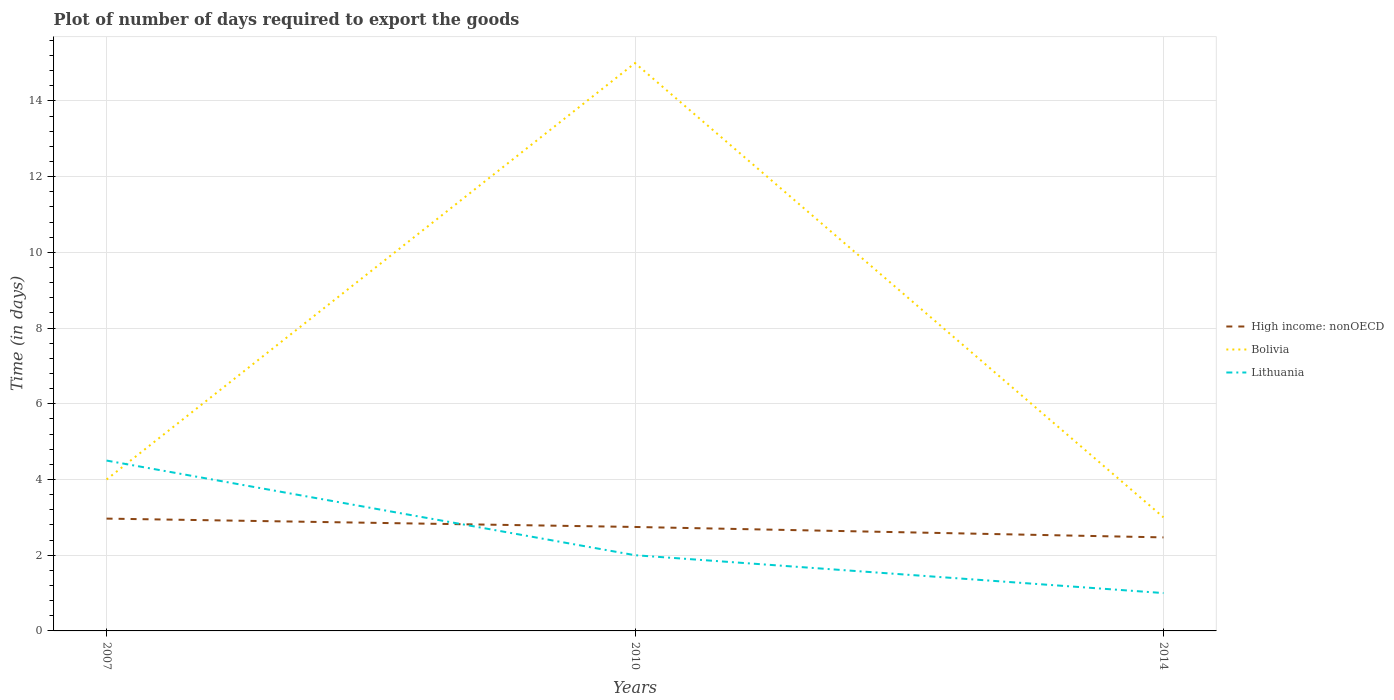Across all years, what is the maximum time required to export goods in Bolivia?
Your answer should be very brief. 3. In which year was the time required to export goods in High income: nonOECD maximum?
Provide a short and direct response. 2014. What is the total time required to export goods in Lithuania in the graph?
Provide a succinct answer. 3.5. What is the difference between the highest and the second highest time required to export goods in High income: nonOECD?
Keep it short and to the point. 0.5. Is the time required to export goods in Bolivia strictly greater than the time required to export goods in Lithuania over the years?
Your answer should be very brief. No. How many lines are there?
Your response must be concise. 3. How many years are there in the graph?
Keep it short and to the point. 3. What is the difference between two consecutive major ticks on the Y-axis?
Give a very brief answer. 2. Does the graph contain any zero values?
Ensure brevity in your answer.  No. Does the graph contain grids?
Give a very brief answer. Yes. Where does the legend appear in the graph?
Keep it short and to the point. Center right. How many legend labels are there?
Provide a short and direct response. 3. What is the title of the graph?
Your response must be concise. Plot of number of days required to export the goods. Does "Mauritius" appear as one of the legend labels in the graph?
Provide a succinct answer. No. What is the label or title of the X-axis?
Provide a short and direct response. Years. What is the label or title of the Y-axis?
Offer a terse response. Time (in days). What is the Time (in days) of High income: nonOECD in 2007?
Offer a very short reply. 2.97. What is the Time (in days) of Bolivia in 2007?
Provide a short and direct response. 4. What is the Time (in days) of Lithuania in 2007?
Your answer should be very brief. 4.5. What is the Time (in days) of High income: nonOECD in 2010?
Provide a succinct answer. 2.75. What is the Time (in days) in Bolivia in 2010?
Keep it short and to the point. 15. What is the Time (in days) in Lithuania in 2010?
Your answer should be very brief. 2. What is the Time (in days) in High income: nonOECD in 2014?
Your answer should be compact. 2.47. What is the Time (in days) in Bolivia in 2014?
Provide a short and direct response. 3. What is the Time (in days) in Lithuania in 2014?
Make the answer very short. 1. Across all years, what is the maximum Time (in days) in High income: nonOECD?
Your answer should be compact. 2.97. Across all years, what is the maximum Time (in days) of Lithuania?
Keep it short and to the point. 4.5. Across all years, what is the minimum Time (in days) in High income: nonOECD?
Offer a terse response. 2.47. What is the total Time (in days) of High income: nonOECD in the graph?
Make the answer very short. 8.18. What is the total Time (in days) of Lithuania in the graph?
Your response must be concise. 7.5. What is the difference between the Time (in days) of High income: nonOECD in 2007 and that in 2010?
Your answer should be compact. 0.22. What is the difference between the Time (in days) of High income: nonOECD in 2007 and that in 2014?
Ensure brevity in your answer.  0.5. What is the difference between the Time (in days) in Bolivia in 2007 and that in 2014?
Give a very brief answer. 1. What is the difference between the Time (in days) of Lithuania in 2007 and that in 2014?
Your response must be concise. 3.5. What is the difference between the Time (in days) in High income: nonOECD in 2010 and that in 2014?
Offer a terse response. 0.28. What is the difference between the Time (in days) in Lithuania in 2010 and that in 2014?
Make the answer very short. 1. What is the difference between the Time (in days) in High income: nonOECD in 2007 and the Time (in days) in Bolivia in 2010?
Provide a short and direct response. -12.03. What is the difference between the Time (in days) of High income: nonOECD in 2007 and the Time (in days) of Lithuania in 2010?
Provide a short and direct response. 0.97. What is the difference between the Time (in days) of High income: nonOECD in 2007 and the Time (in days) of Bolivia in 2014?
Ensure brevity in your answer.  -0.03. What is the difference between the Time (in days) in High income: nonOECD in 2007 and the Time (in days) in Lithuania in 2014?
Your response must be concise. 1.97. What is the difference between the Time (in days) in High income: nonOECD in 2010 and the Time (in days) in Bolivia in 2014?
Offer a very short reply. -0.25. What is the difference between the Time (in days) in High income: nonOECD in 2010 and the Time (in days) in Lithuania in 2014?
Offer a terse response. 1.75. What is the difference between the Time (in days) of Bolivia in 2010 and the Time (in days) of Lithuania in 2014?
Make the answer very short. 14. What is the average Time (in days) of High income: nonOECD per year?
Give a very brief answer. 2.73. What is the average Time (in days) in Bolivia per year?
Your answer should be very brief. 7.33. What is the average Time (in days) of Lithuania per year?
Offer a terse response. 2.5. In the year 2007, what is the difference between the Time (in days) of High income: nonOECD and Time (in days) of Bolivia?
Keep it short and to the point. -1.03. In the year 2007, what is the difference between the Time (in days) in High income: nonOECD and Time (in days) in Lithuania?
Provide a succinct answer. -1.53. In the year 2010, what is the difference between the Time (in days) of High income: nonOECD and Time (in days) of Bolivia?
Offer a terse response. -12.25. In the year 2010, what is the difference between the Time (in days) in High income: nonOECD and Time (in days) in Lithuania?
Give a very brief answer. 0.75. In the year 2014, what is the difference between the Time (in days) of High income: nonOECD and Time (in days) of Bolivia?
Make the answer very short. -0.53. In the year 2014, what is the difference between the Time (in days) of High income: nonOECD and Time (in days) of Lithuania?
Ensure brevity in your answer.  1.47. In the year 2014, what is the difference between the Time (in days) of Bolivia and Time (in days) of Lithuania?
Your answer should be very brief. 2. What is the ratio of the Time (in days) in High income: nonOECD in 2007 to that in 2010?
Your answer should be very brief. 1.08. What is the ratio of the Time (in days) of Bolivia in 2007 to that in 2010?
Offer a very short reply. 0.27. What is the ratio of the Time (in days) in Lithuania in 2007 to that in 2010?
Your response must be concise. 2.25. What is the ratio of the Time (in days) of High income: nonOECD in 2007 to that in 2014?
Make the answer very short. 1.2. What is the ratio of the Time (in days) in High income: nonOECD in 2010 to that in 2014?
Keep it short and to the point. 1.11. What is the difference between the highest and the second highest Time (in days) of High income: nonOECD?
Make the answer very short. 0.22. What is the difference between the highest and the second highest Time (in days) of Bolivia?
Make the answer very short. 11. What is the difference between the highest and the lowest Time (in days) in High income: nonOECD?
Keep it short and to the point. 0.5. What is the difference between the highest and the lowest Time (in days) in Bolivia?
Offer a terse response. 12. What is the difference between the highest and the lowest Time (in days) in Lithuania?
Provide a short and direct response. 3.5. 